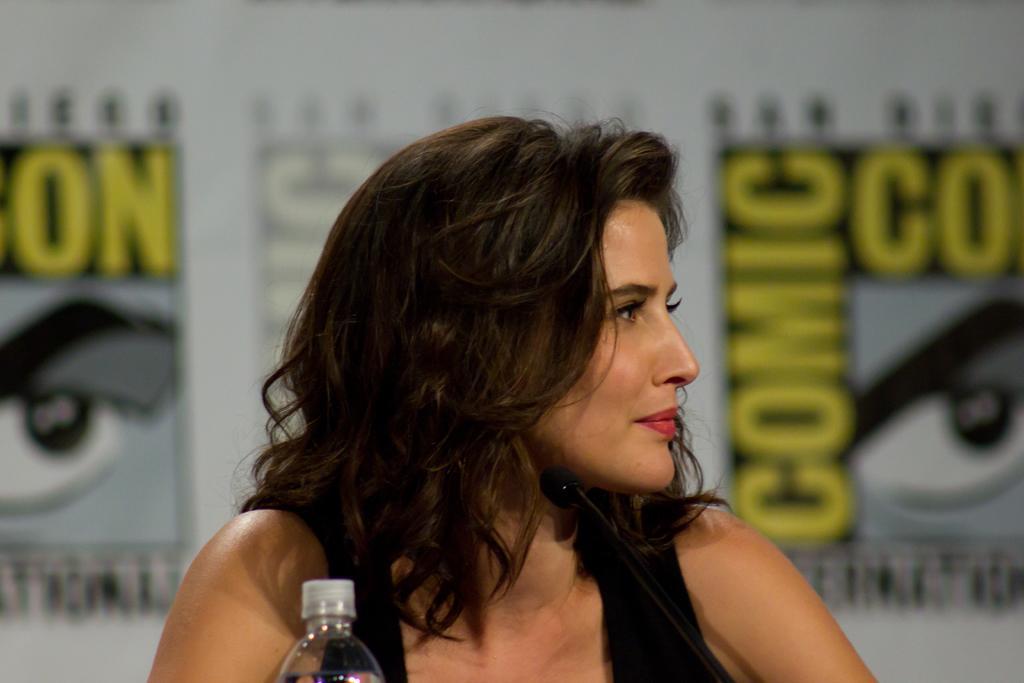Describe this image in one or two sentences. In this image we can see a lady, in front of her there is a bottle, and a mic, behind her there are poster with some text and images on it, also the background is blurred. 